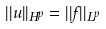<formula> <loc_0><loc_0><loc_500><loc_500>| | u | | _ { H ^ { p } } = | | f | | _ { L ^ { p } }</formula> 